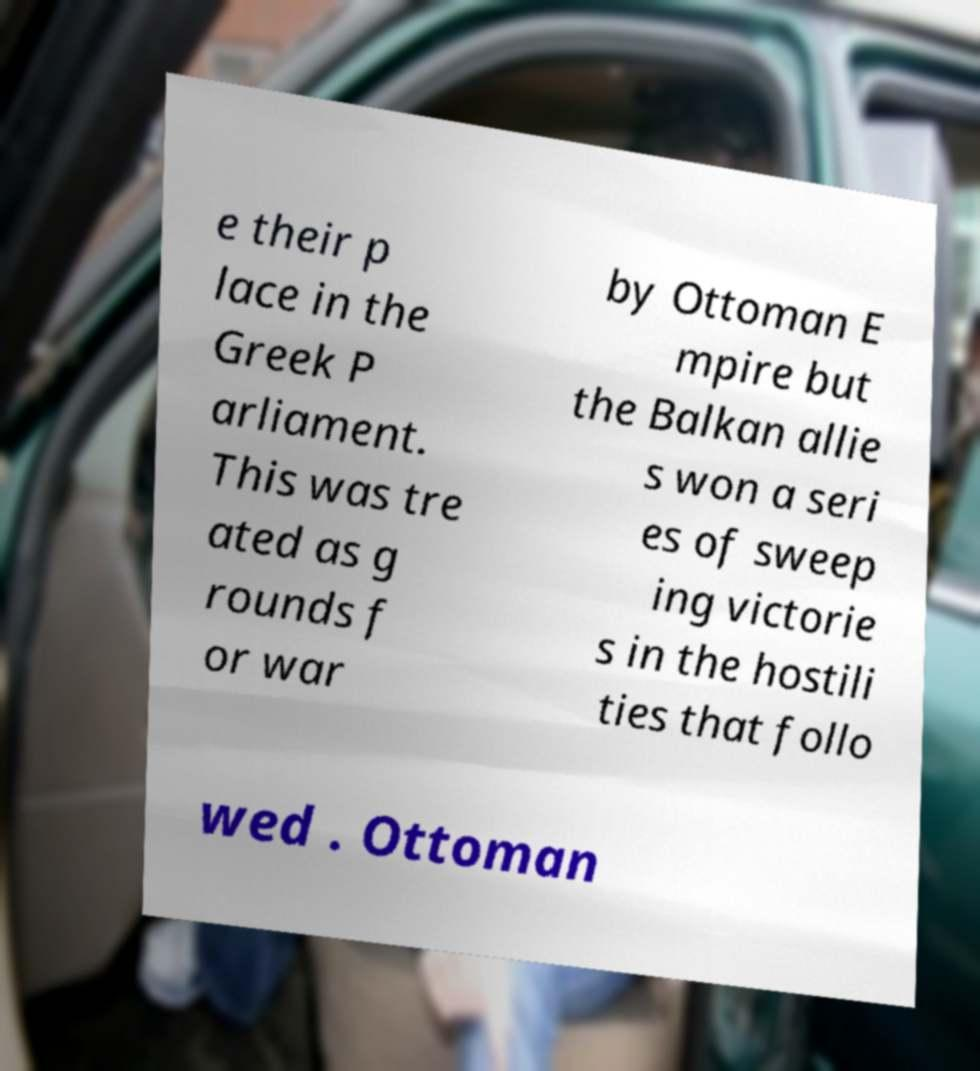What messages or text are displayed in this image? I need them in a readable, typed format. e their p lace in the Greek P arliament. This was tre ated as g rounds f or war by Ottoman E mpire but the Balkan allie s won a seri es of sweep ing victorie s in the hostili ties that follo wed . Ottoman 